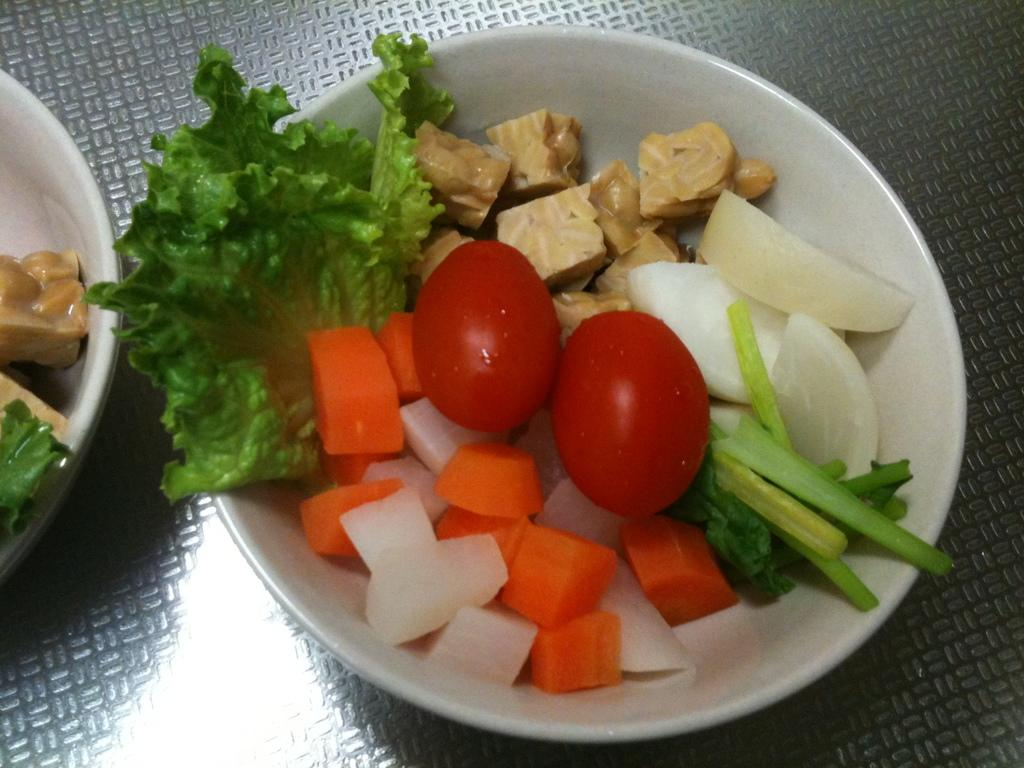How many bowls are visible in the image? There are two bowls in the image. What is inside the bowls? The bowls contain diced vegetables, and they may also contain whole vegetables. Where are the bowls likely placed? The bowls are likely placed on a table. In what type of setting is the image likely taken? The image is likely taken in a room. What causes the vegetables to feel shame in the image? There is no indication in the image that the vegetables feel shame, as vegetables do not have emotions. 